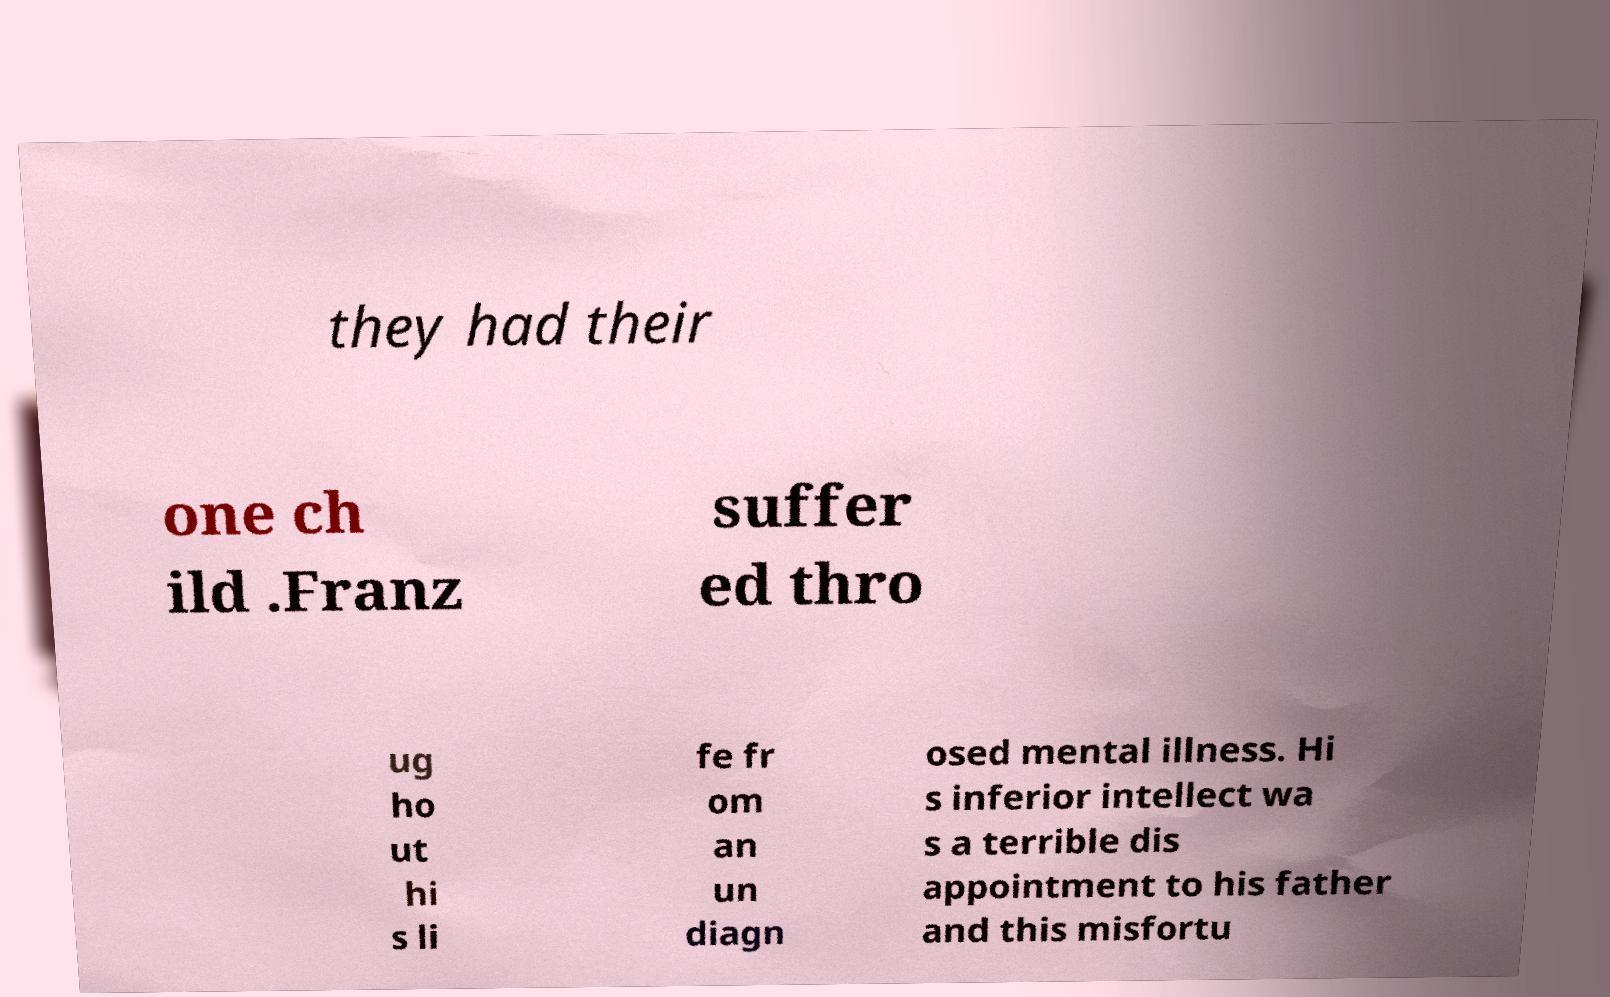For documentation purposes, I need the text within this image transcribed. Could you provide that? they had their one ch ild .Franz suffer ed thro ug ho ut hi s li fe fr om an un diagn osed mental illness. Hi s inferior intellect wa s a terrible dis appointment to his father and this misfortu 